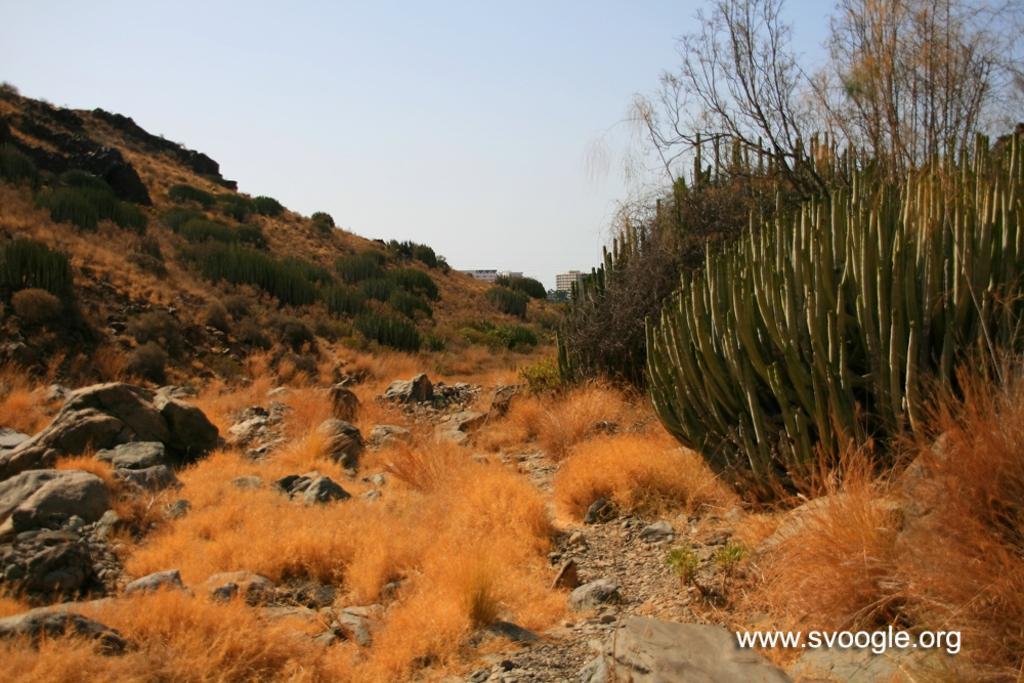Could you give a brief overview of what you see in this image? In this image there is the sky towards the top of the image, there are buildings, there is a hill towards the right of the image, there are plants, there are rocks, there is text towards the bottom of the image. 